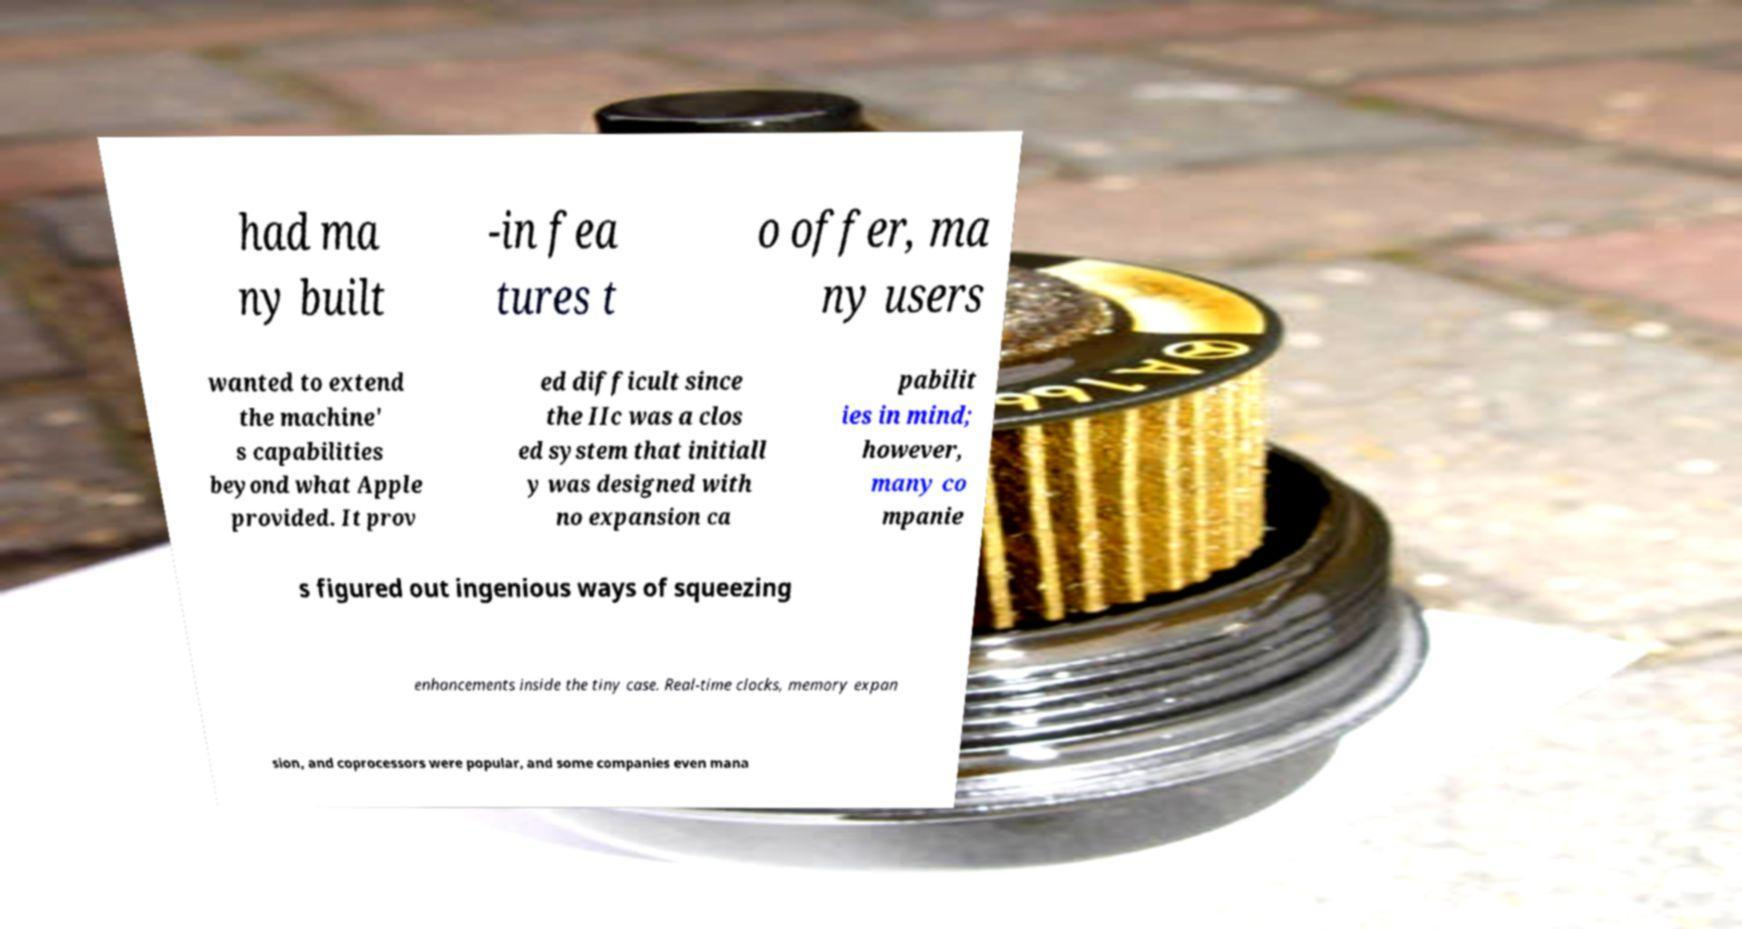I need the written content from this picture converted into text. Can you do that? had ma ny built -in fea tures t o offer, ma ny users wanted to extend the machine' s capabilities beyond what Apple provided. It prov ed difficult since the IIc was a clos ed system that initiall y was designed with no expansion ca pabilit ies in mind; however, many co mpanie s figured out ingenious ways of squeezing enhancements inside the tiny case. Real-time clocks, memory expan sion, and coprocessors were popular, and some companies even mana 